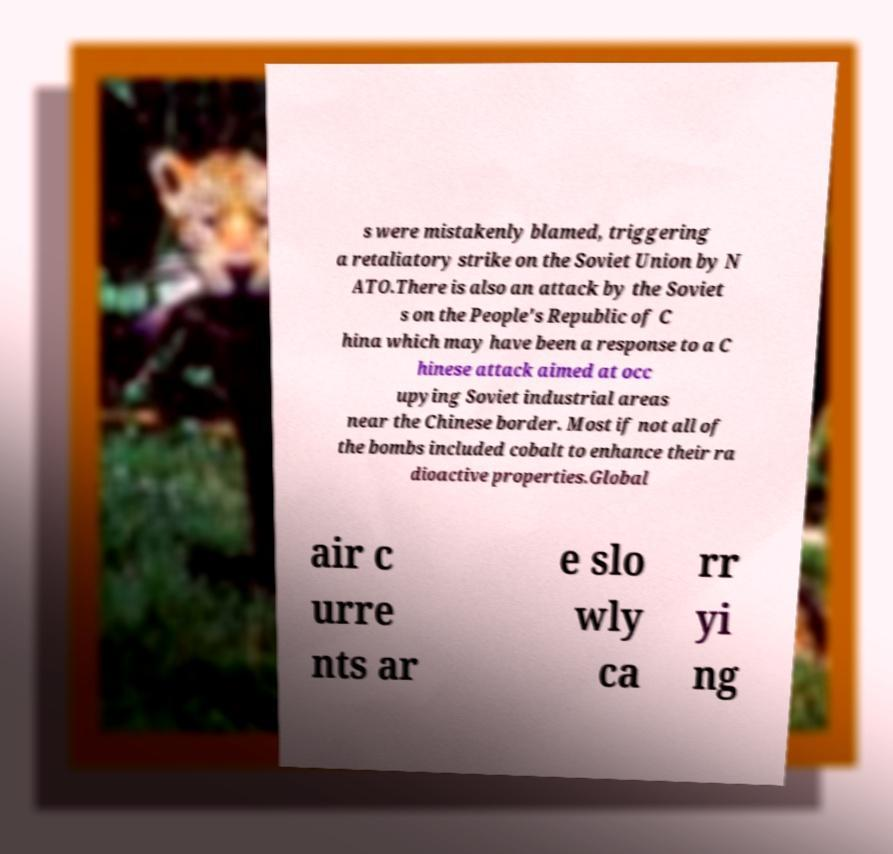I need the written content from this picture converted into text. Can you do that? s were mistakenly blamed, triggering a retaliatory strike on the Soviet Union by N ATO.There is also an attack by the Soviet s on the People's Republic of C hina which may have been a response to a C hinese attack aimed at occ upying Soviet industrial areas near the Chinese border. Most if not all of the bombs included cobalt to enhance their ra dioactive properties.Global air c urre nts ar e slo wly ca rr yi ng 